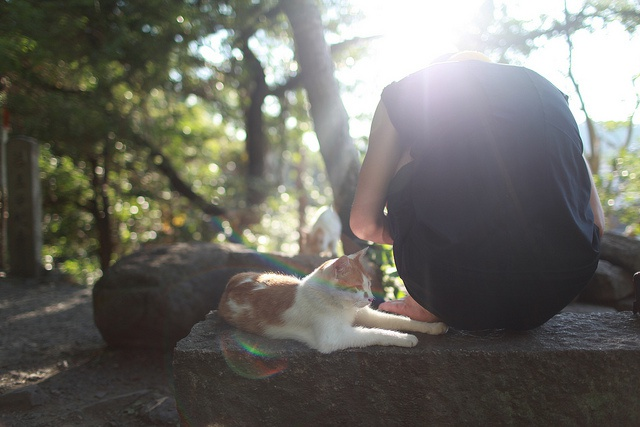Describe the objects in this image and their specific colors. I can see people in black, gray, darkgray, and lavender tones and cat in black, gray, and darkgray tones in this image. 